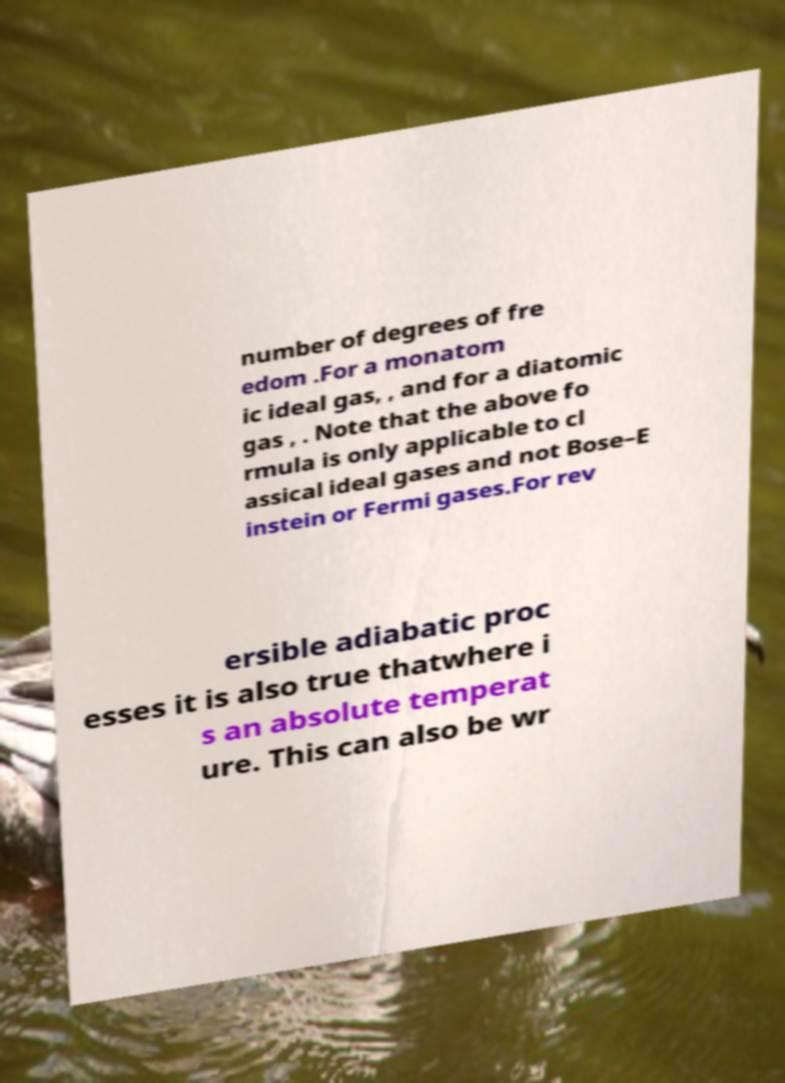What messages or text are displayed in this image? I need them in a readable, typed format. number of degrees of fre edom .For a monatom ic ideal gas, , and for a diatomic gas , . Note that the above fo rmula is only applicable to cl assical ideal gases and not Bose–E instein or Fermi gases.For rev ersible adiabatic proc esses it is also true thatwhere i s an absolute temperat ure. This can also be wr 